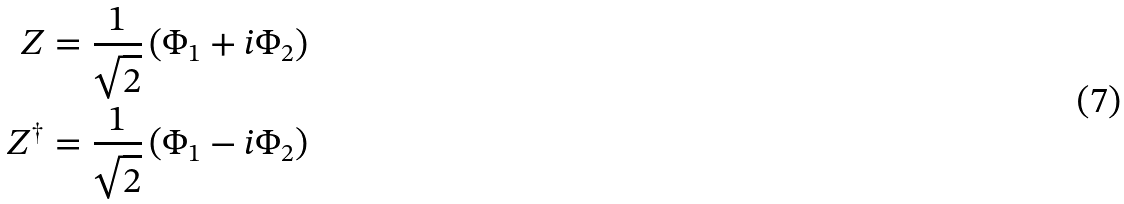Convert formula to latex. <formula><loc_0><loc_0><loc_500><loc_500>Z & = \frac { 1 } { \sqrt { 2 } } \left ( \Phi _ { 1 } + i \Phi _ { 2 } \right ) \\ Z ^ { \dag } & = \frac { 1 } { \sqrt { 2 } } \left ( \Phi _ { 1 } - i \Phi _ { 2 } \right )</formula> 